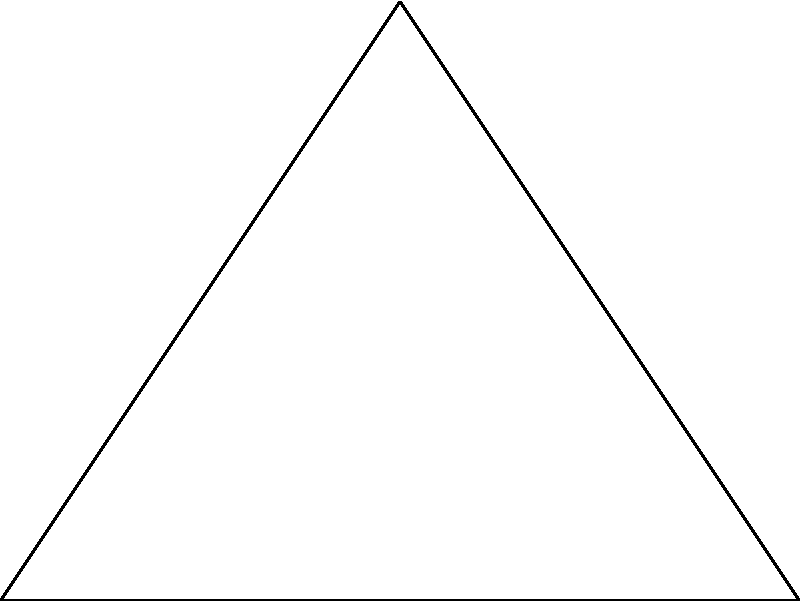In your historical footage, you've identified two landmarks (A and B) and a camera position (C). The distance between landmarks A and B is 500 meters. The angle between the camera's line of sight to landmark A and the line connecting A and B is 60°. Using trigonometric ratios, calculate the distance between the camera position (C) and landmark A to determine the scale of your footage. Let's approach this step-by-step:

1) In the triangle ACD:
   - We know the angle at C is 60°
   - AD is perpendicular to AB, so angle CAD is 90°
   - Therefore, triangle ACD is a 30-60-90 triangle

2) In a 30-60-90 triangle, if the shortest side (opposite to 30°) is x:
   - The hypotenuse (opposite to 90°) is 2x
   - The remaining side (opposite to 60°) is $x\sqrt{3}$

3) We need to find AD first:
   - AB = 500 m
   - In a 30-60-90 triangle, AD (shortest side) = $\frac{1}{2}$AB
   - AD = $\frac{1}{2} \times 500 = 250$ m

4) Now we can find AC:
   - If AD = x = 250 m
   - Then AC (hypotenuse) = 2x = 2 × 250 = 500 m

Therefore, the distance between the camera position (C) and landmark A is 500 meters.
Answer: 500 m 